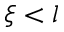Convert formula to latex. <formula><loc_0><loc_0><loc_500><loc_500>\xi < l</formula> 